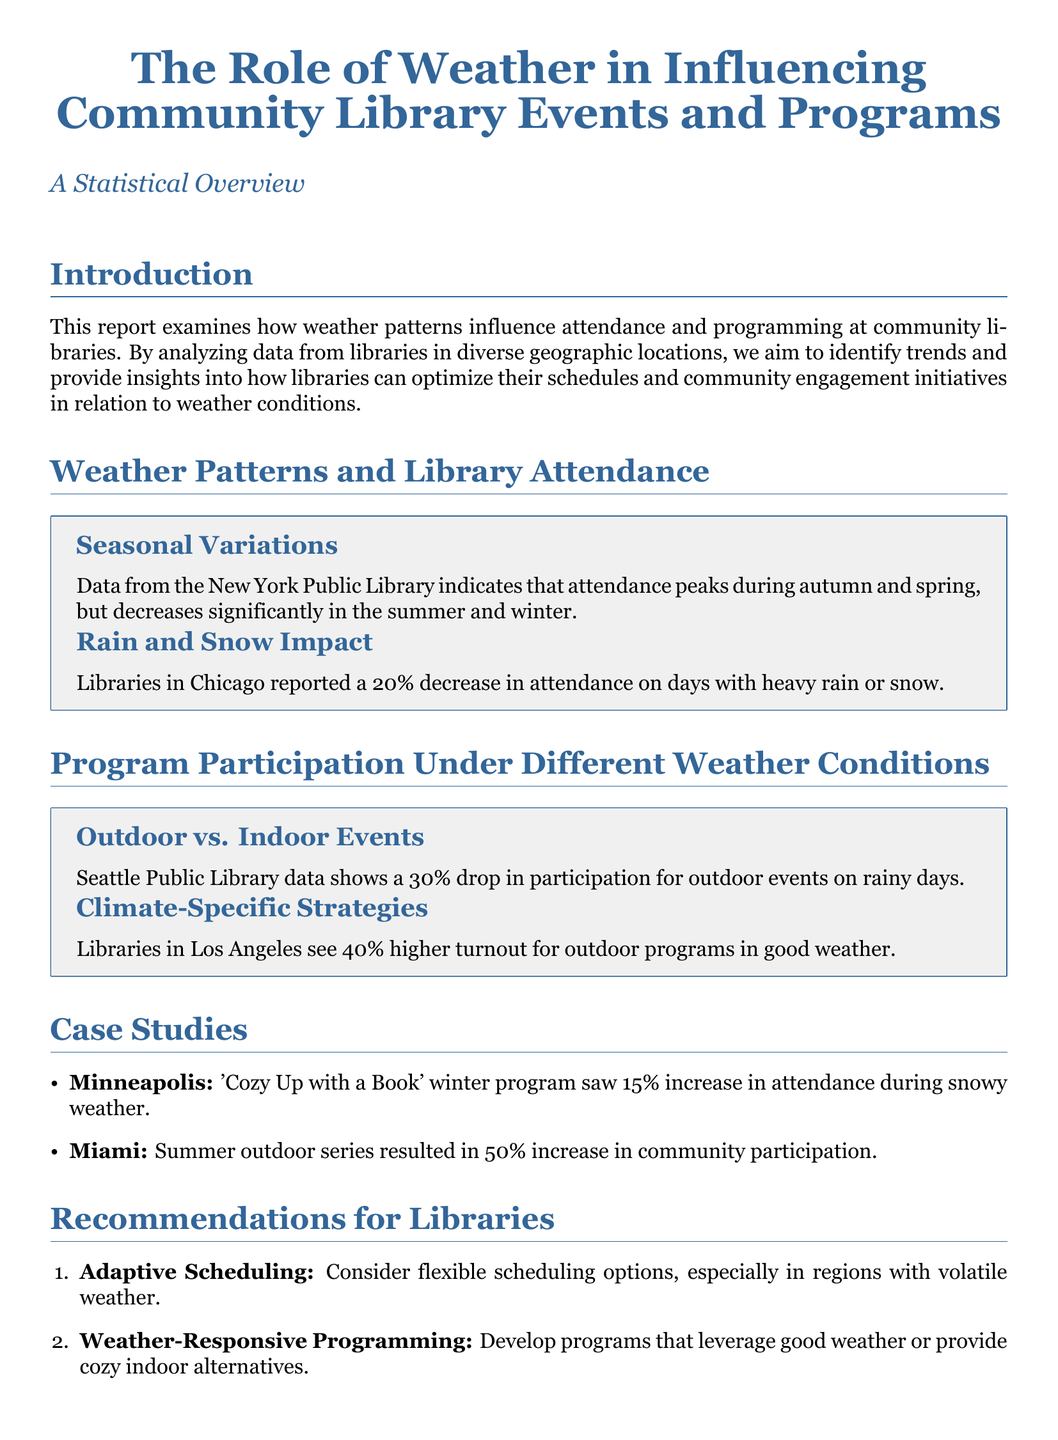What is the main focus of the report? The report examines how weather patterns influence attendance and programming at community libraries.
Answer: Weather patterns influence attendance and programming What percentage decrease in attendance is reported on heavy rain or snow days in Chicago? The document states a 20% decrease in attendance on heavy rain or snow days in Chicago.
Answer: 20% In which seasons does attendance peak according to the New York Public Library data? The data indicates that attendance peaks during autumn and spring.
Answer: Autumn and spring How much higher is the turnout for outdoor programs in good weather in Los Angeles? The document notes a 40% higher turnout for outdoor programs in good weather in Los Angeles.
Answer: 40% What is one of the recommendations for libraries in the report? The report recommends developing programs that leverage good weather or provide cozy indoor alternatives.
Answer: Weather-Responsive Programming What was the attendance increase percentage for the 'Cozy Up with a Book' winter program during snowy weather in Minneapolis? The attendance increase was 15% during snowy weather for this program.
Answer: 15% How much drop in participation for outdoor events is noted on rainy days in Seattle? The document reports a 30% drop in participation for outdoor events on rainy days in Seattle.
Answer: 30% What type of scheduling does the report suggest libraries consider? The report suggests considering adaptive scheduling options, especially in regions with volatile weather.
Answer: Adaptive Scheduling What is the key conclusion of the report regarding weather conditions and library events? The conclusion states that weather conditions significantly affect library event attendance and program participation.
Answer: Significantly affect attendance and participation 